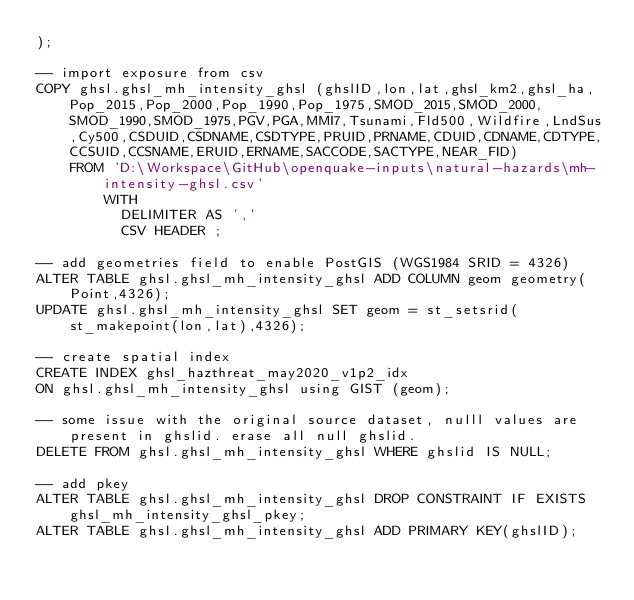Convert code to text. <code><loc_0><loc_0><loc_500><loc_500><_SQL_>);

-- import exposure from csv
COPY ghsl.ghsl_mh_intensity_ghsl (ghslID,lon,lat,ghsl_km2,ghsl_ha,Pop_2015,Pop_2000,Pop_1990,Pop_1975,SMOD_2015,SMOD_2000,SMOD_1990,SMOD_1975,PGV,PGA,MMI7,Tsunami,Fld500,Wildfire,LndSus,Cy500,CSDUID,CSDNAME,CSDTYPE,PRUID,PRNAME,CDUID,CDNAME,CDTYPE,CCSUID,CCSNAME,ERUID,ERNAME,SACCODE,SACTYPE,NEAR_FID)
    FROM 'D:\Workspace\GitHub\openquake-inputs\natural-hazards\mh-intensity-ghsl.csv'
        WITH 
          DELIMITER AS ','
          CSV HEADER ;

-- add geometries field to enable PostGIS (WGS1984 SRID = 4326)
ALTER TABLE ghsl.ghsl_mh_intensity_ghsl ADD COLUMN geom geometry(Point,4326);
UPDATE ghsl.ghsl_mh_intensity_ghsl SET geom = st_setsrid(st_makepoint(lon,lat),4326);

-- create spatial index
CREATE INDEX ghsl_hazthreat_may2020_v1p2_idx
ON ghsl.ghsl_mh_intensity_ghsl using GIST (geom);

-- some issue with the original source dataset, nulll values are present in ghslid. erase all null ghslid. 
DELETE FROM ghsl.ghsl_mh_intensity_ghsl WHERE ghslid IS NULL;

-- add pkey
ALTER TABLE ghsl.ghsl_mh_intensity_ghsl DROP CONSTRAINT IF EXISTS ghsl_mh_intensity_ghsl_pkey;
ALTER TABLE ghsl.ghsl_mh_intensity_ghsl ADD PRIMARY KEY(ghslID);</code> 